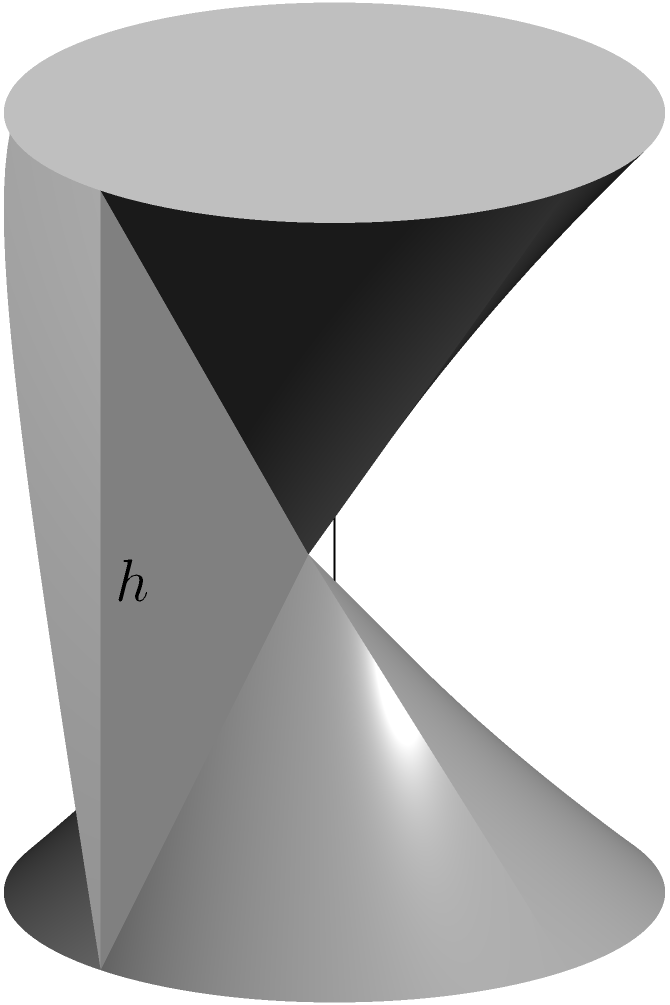As a tradesperson, you're tasked with installing a cylindrical water tank for a client who wants to save on costs. The tank has a radius of 2 meters and a height of 5 meters. Calculate the volume of the tank in cubic meters. How would you explain to your client the importance of accurately calculating the volume for proper installation and potential cost savings? To calculate the volume of a cylindrical tank, we use the formula:

$$V = \pi r^2 h$$

Where:
$V$ = volume
$r$ = radius
$h$ = height

Given:
$r = 2$ meters
$h = 5$ meters

Step 1: Substitute the values into the formula:
$$V = \pi (2)^2 (5)$$

Step 2: Simplify the exponent:
$$V = \pi (4) (5)$$

Step 3: Multiply the numbers:
$$V = 20\pi$$

Step 4: Calculate the final value (rounded to two decimal places):
$$V \approx 62.83 \text{ cubic meters}$$

Explanation to the client:
Accurate volume calculation is crucial for proper installation and cost savings. It ensures:
1. Correct sizing of the tank for the client's needs
2. Appropriate foundation preparation
3. Accurate estimation of materials and labor costs
4. Proper water pressure calculations
5. Compliance with local building codes

By providing this precise calculation, you demonstrate professionalism and help the client make informed decisions about their water storage needs and associated costs.
Answer: $62.83 \text{ m}^3$ 